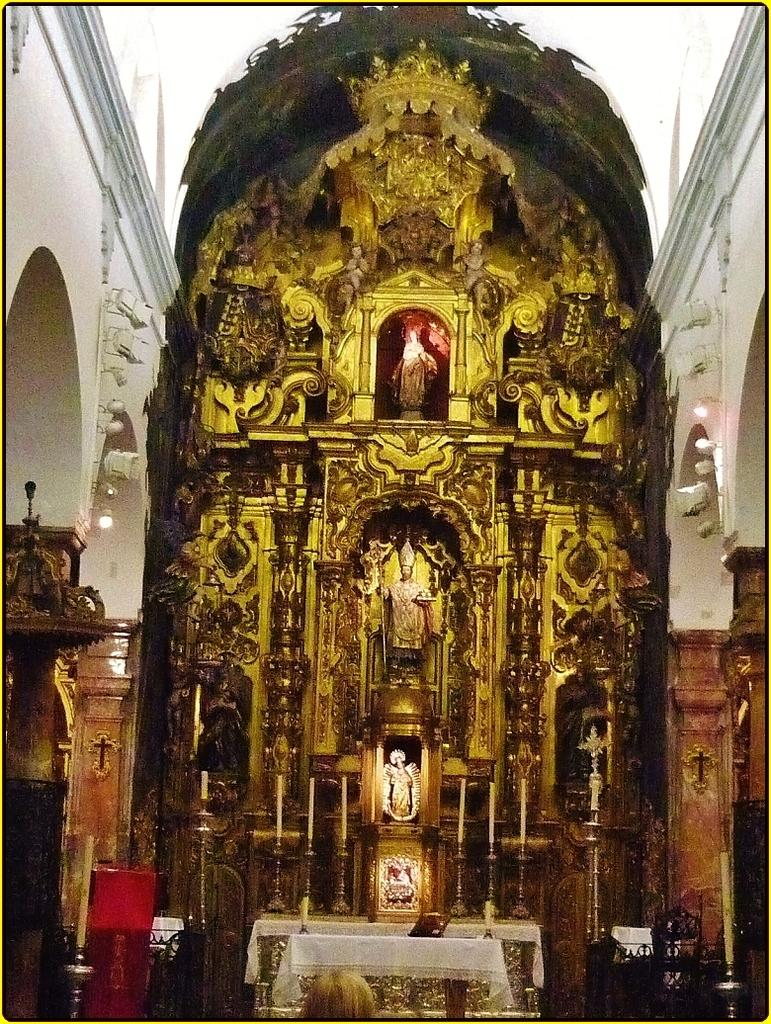What type of art is present in the image? There are sculptures in the image. What is another object present in the image? There are candles in the image. What type of architectural feature can be seen in the image? There is a wall and pillars in the image. What color is the cloth present in the image? There is a white color cloth in the image. What type of vegetable is being smashed by the sculpture in the image? There is no vegetable or smashing action present in the image. 